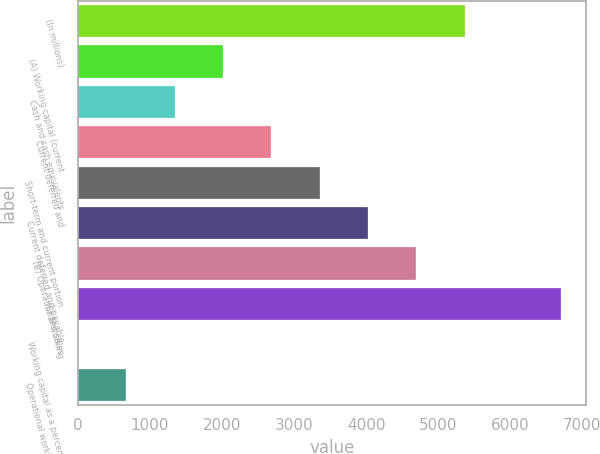<chart> <loc_0><loc_0><loc_500><loc_500><bar_chart><fcel>(In millions)<fcel>(A) Working capital (current<fcel>Cash and cash equivalents<fcel>Current deferred and<fcel>Short-term and current portion<fcel>Current deferred and payable<fcel>(B) Operational working<fcel>(C) Net sales<fcel>Working capital as a percent<fcel>Operational working capital as<nl><fcel>5368.7<fcel>2014.45<fcel>1343.6<fcel>2685.3<fcel>3356.15<fcel>4027<fcel>4697.85<fcel>6710.4<fcel>1.9<fcel>672.75<nl></chart> 